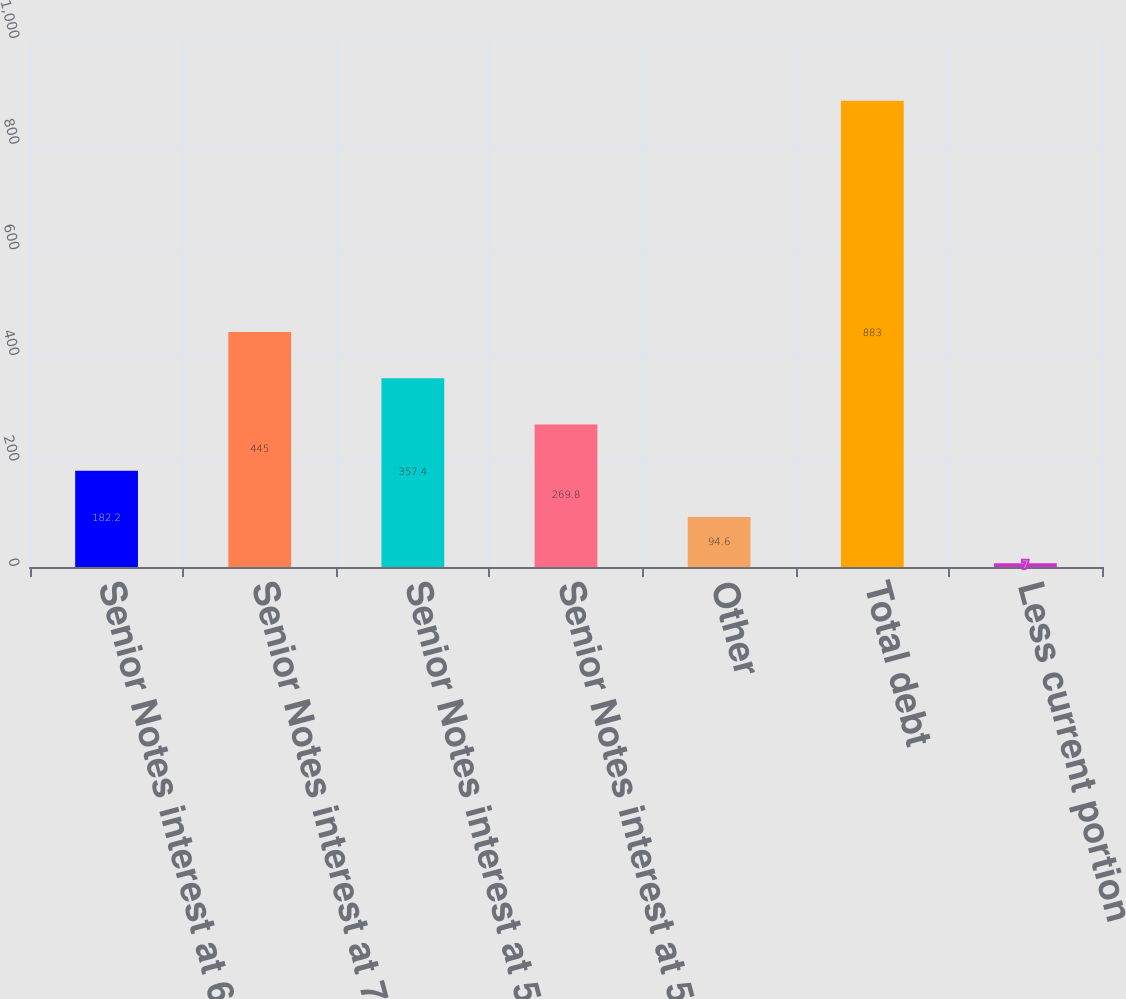Convert chart to OTSL. <chart><loc_0><loc_0><loc_500><loc_500><bar_chart><fcel>Senior Notes interest at 65<fcel>Senior Notes interest at 725<fcel>Senior Notes interest at 565<fcel>Senior Notes interest at 55<fcel>Other<fcel>Total debt<fcel>Less current portion<nl><fcel>182.2<fcel>445<fcel>357.4<fcel>269.8<fcel>94.6<fcel>883<fcel>7<nl></chart> 